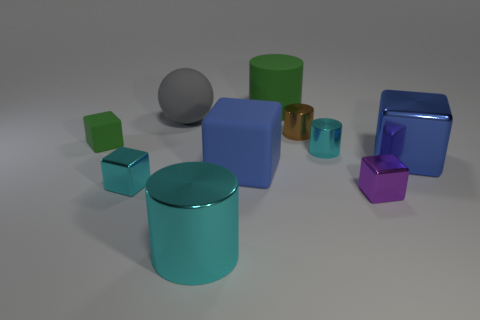Subtract all purple cubes. How many cubes are left? 4 Subtract all tiny cyan shiny blocks. How many blocks are left? 4 Subtract all yellow cubes. Subtract all blue cylinders. How many cubes are left? 5 Subtract all balls. How many objects are left? 9 Subtract 0 purple cylinders. How many objects are left? 10 Subtract all large cyan cubes. Subtract all small brown things. How many objects are left? 9 Add 6 green rubber objects. How many green rubber objects are left? 8 Add 8 cyan cylinders. How many cyan cylinders exist? 10 